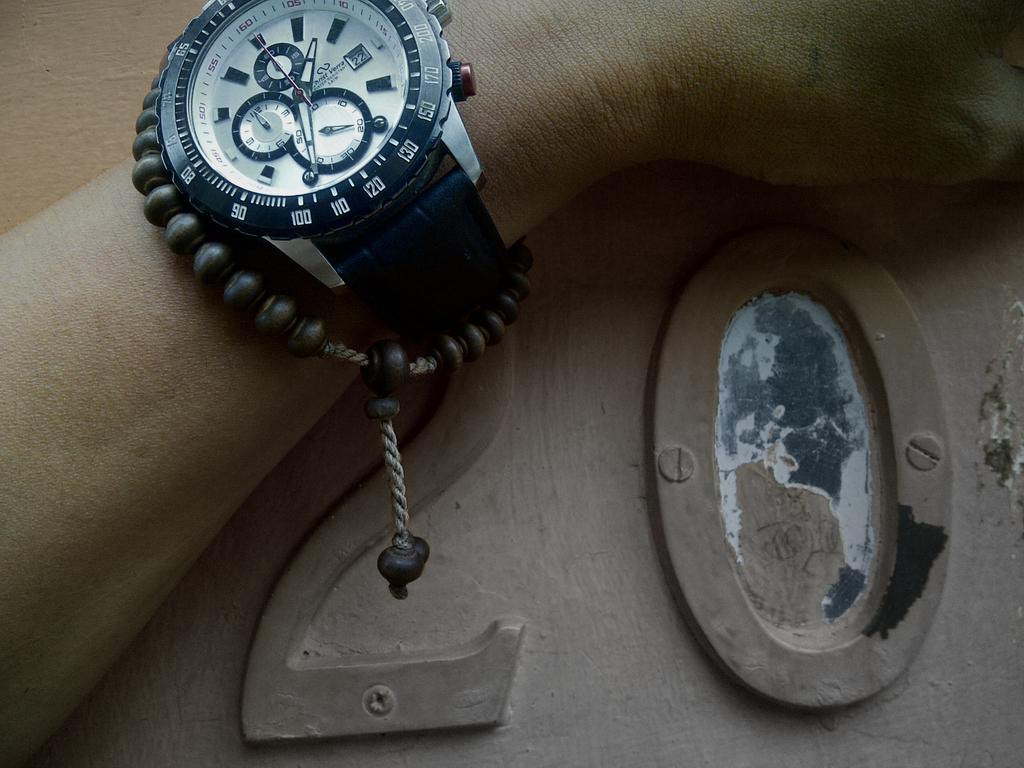<image>
Describe the image concisely. Someone is wearing a watch next to the number 20 on a wall. 